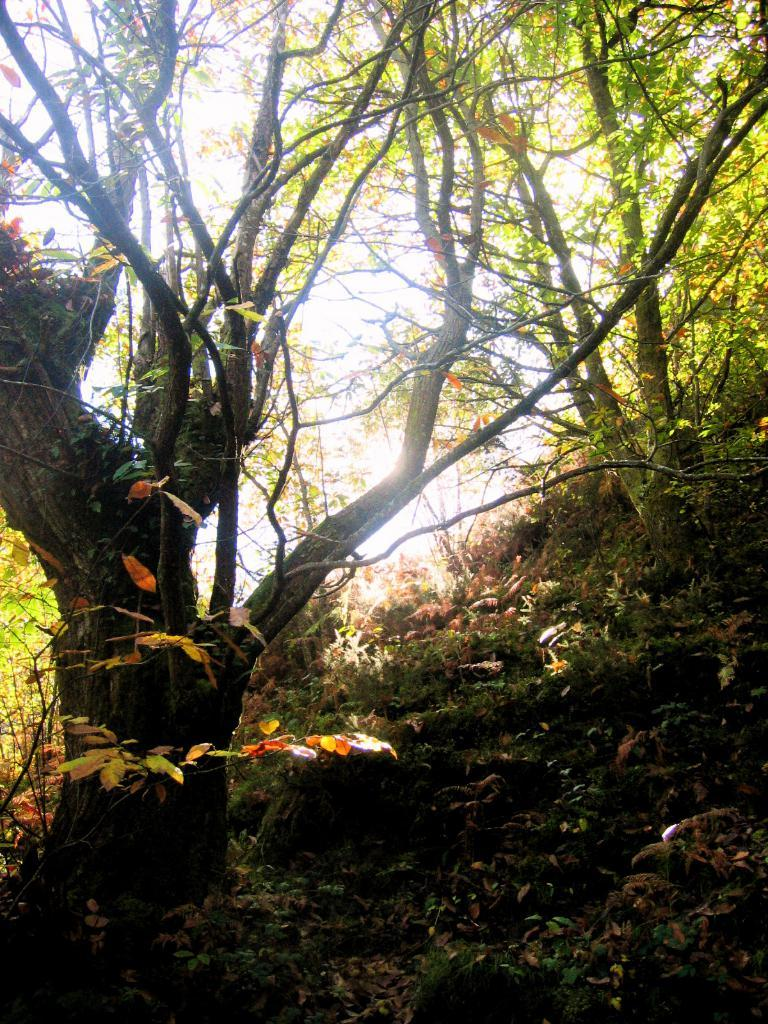Where was the picture taken? The picture was clicked outside. What can be seen on the left side of the image? There is a tree on the left side of the image. What type of vegetation is visible in the image? There are plants visible in the image. What is visible in the background of the image? There is a sky visible in the background of the image. What type of shoe can be seen in the aftermath of the town in the image? There is no shoe, aftermath, or town present in the image. 